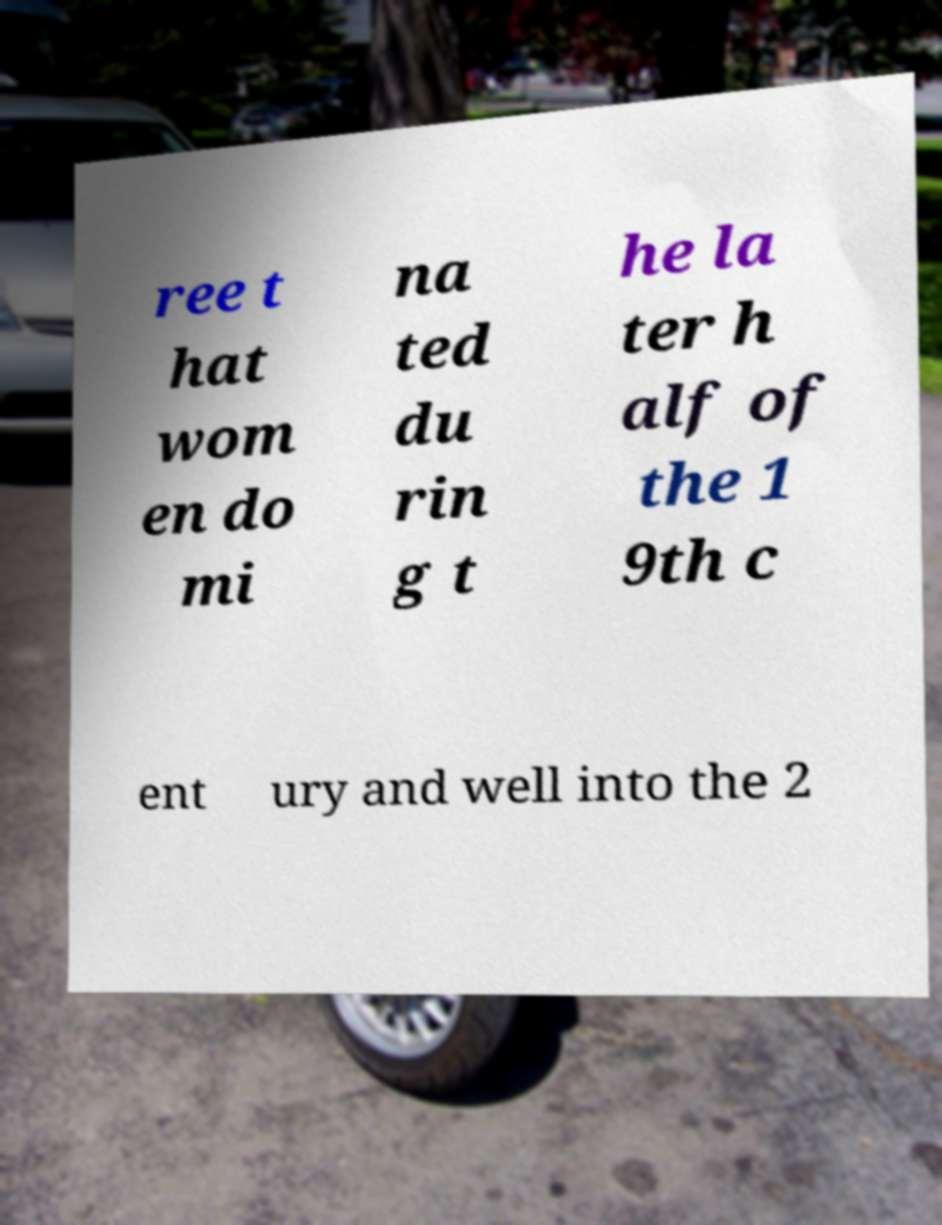Could you extract and type out the text from this image? ree t hat wom en do mi na ted du rin g t he la ter h alf of the 1 9th c ent ury and well into the 2 